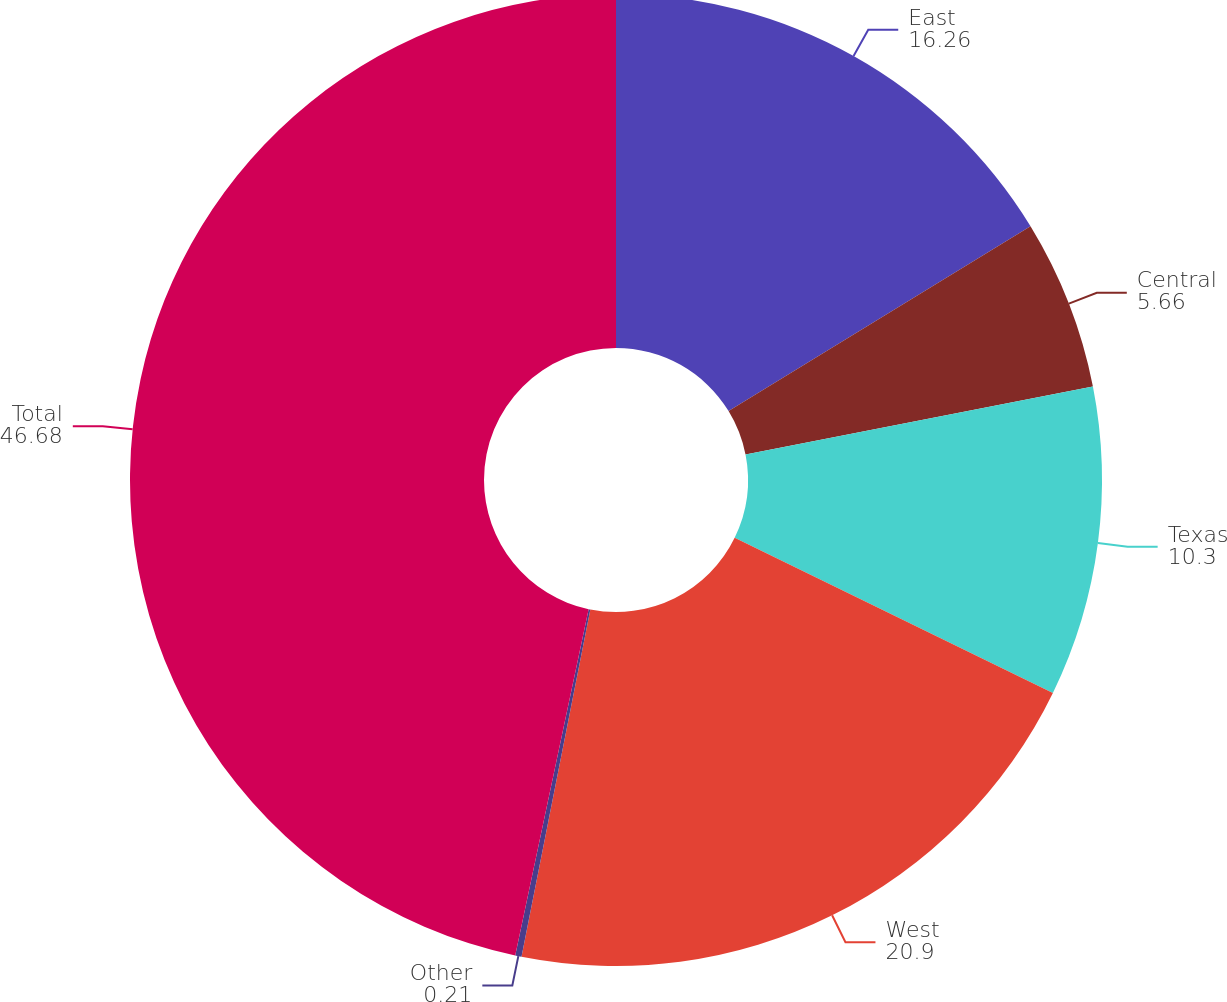<chart> <loc_0><loc_0><loc_500><loc_500><pie_chart><fcel>East<fcel>Central<fcel>Texas<fcel>West<fcel>Other<fcel>Total<nl><fcel>16.26%<fcel>5.66%<fcel>10.3%<fcel>20.9%<fcel>0.21%<fcel>46.68%<nl></chart> 